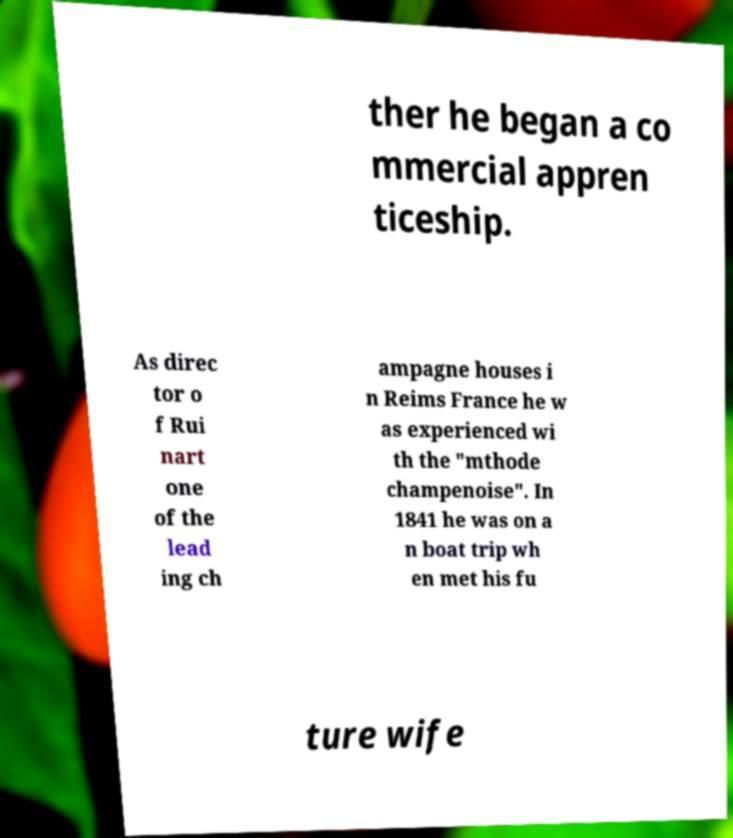Can you read and provide the text displayed in the image?This photo seems to have some interesting text. Can you extract and type it out for me? ther he began a co mmercial appren ticeship. As direc tor o f Rui nart one of the lead ing ch ampagne houses i n Reims France he w as experienced wi th the "mthode champenoise". In 1841 he was on a n boat trip wh en met his fu ture wife 